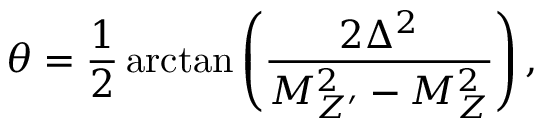<formula> <loc_0><loc_0><loc_500><loc_500>\theta = \frac { 1 } { 2 } \arctan \left ( \frac { 2 \Delta ^ { 2 } } { M _ { Z ^ { \prime } } ^ { 2 } - M _ { Z } ^ { 2 } } \right ) ,</formula> 